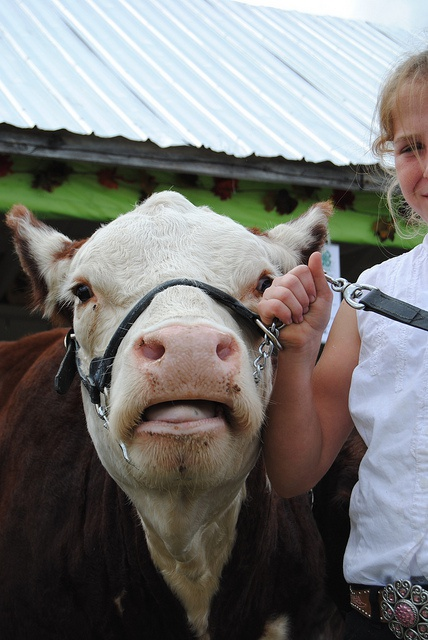Describe the objects in this image and their specific colors. I can see cow in lightblue, black, lightgray, darkgray, and gray tones and people in lightblue, darkgray, brown, and maroon tones in this image. 